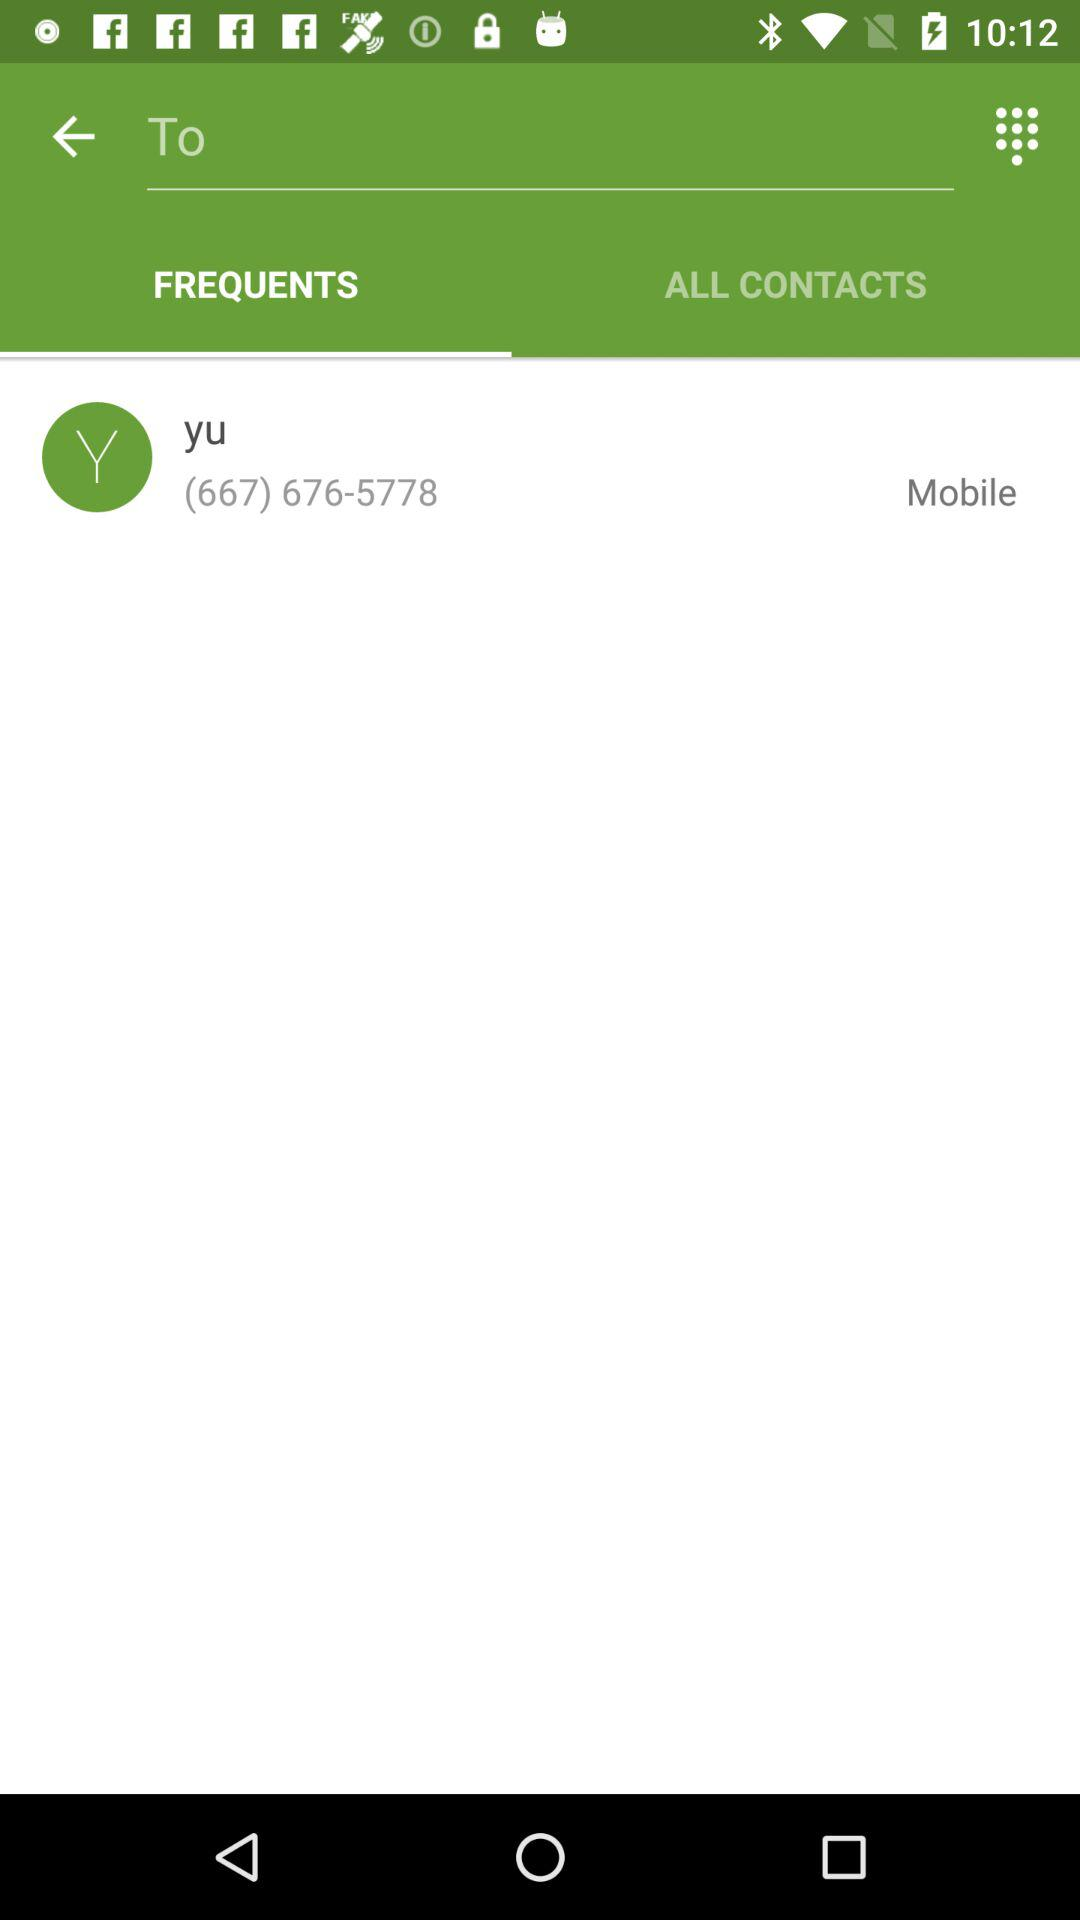Which option is selected? The selected option is "FREQUENTS". 